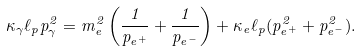Convert formula to latex. <formula><loc_0><loc_0><loc_500><loc_500>\kappa _ { \gamma } \ell _ { p } p _ { \gamma } ^ { 2 } = m _ { e } ^ { 2 } \left ( \frac { 1 } { p _ { e ^ { + } } } + \frac { 1 } { p _ { e ^ { - } } } \right ) + \kappa _ { e } \ell _ { p } ( p _ { e ^ { + } } ^ { 2 } + p _ { e ^ { - } } ^ { 2 } ) .</formula> 